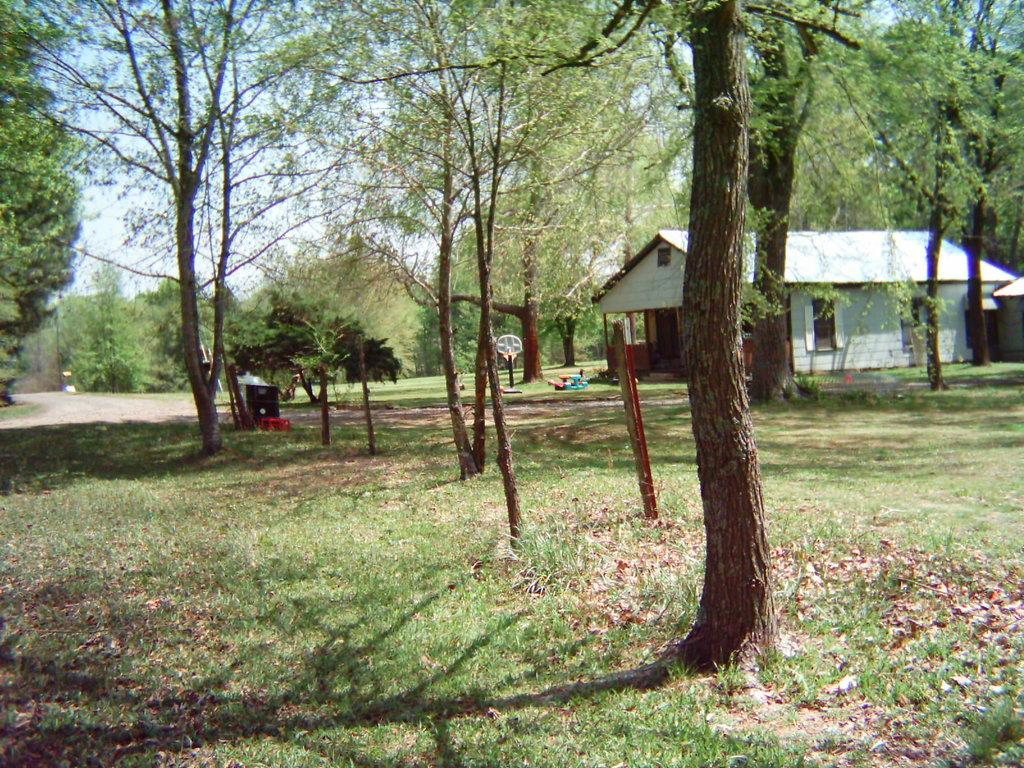What type of structure is visible in the image? There is a building in the image. What is the ground surface like around the building? The building is on a grass ground. Are there any natural elements present in the image? Yes, there are trees around the building. Can you describe any other objects present in the image? There are other objects present in the image, but their specific details are not mentioned in the provided facts. How does the building increase its size in the image? The building does not increase its size in the image; it remains the same size throughout the picture. 